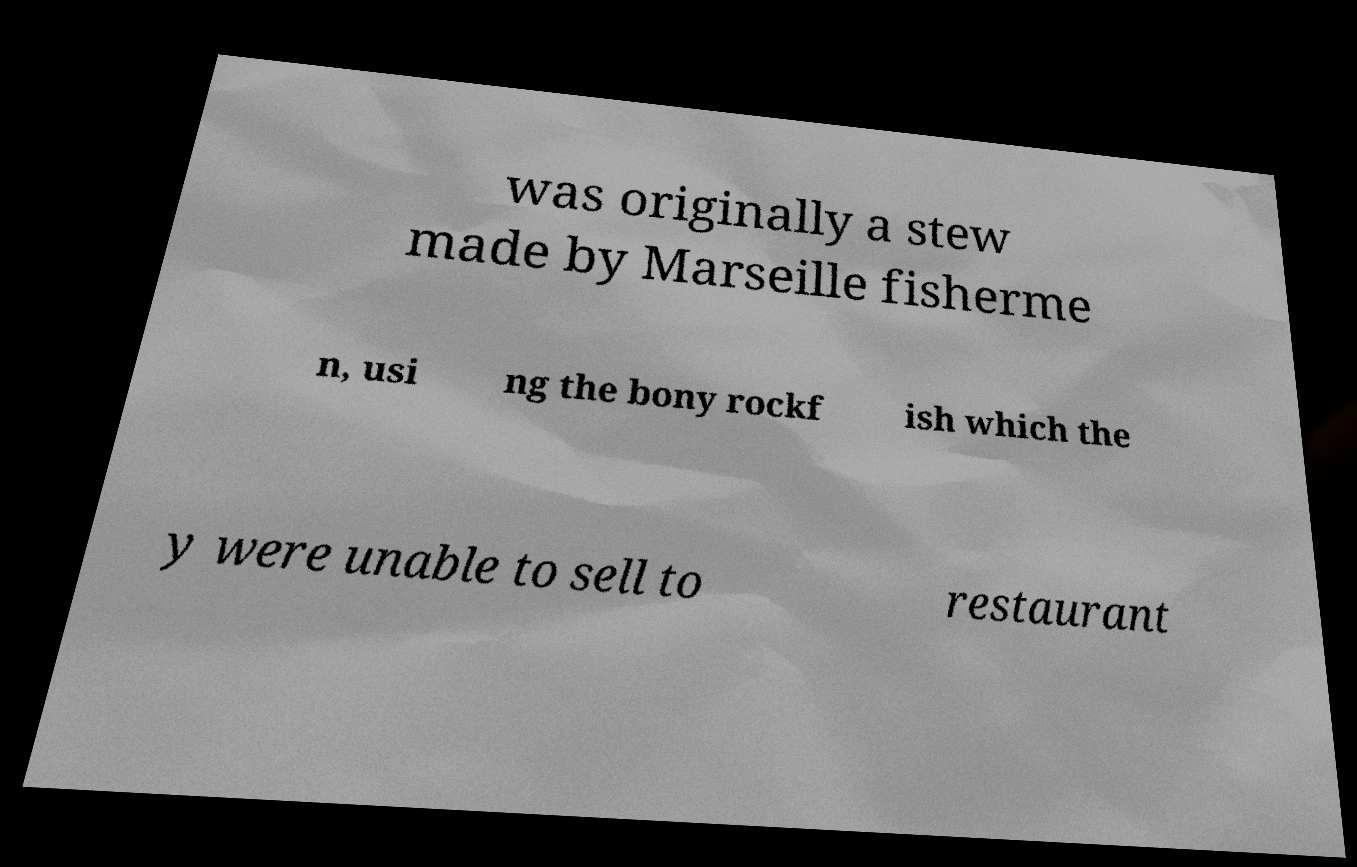Please identify and transcribe the text found in this image. was originally a stew made by Marseille fisherme n, usi ng the bony rockf ish which the y were unable to sell to restaurant 